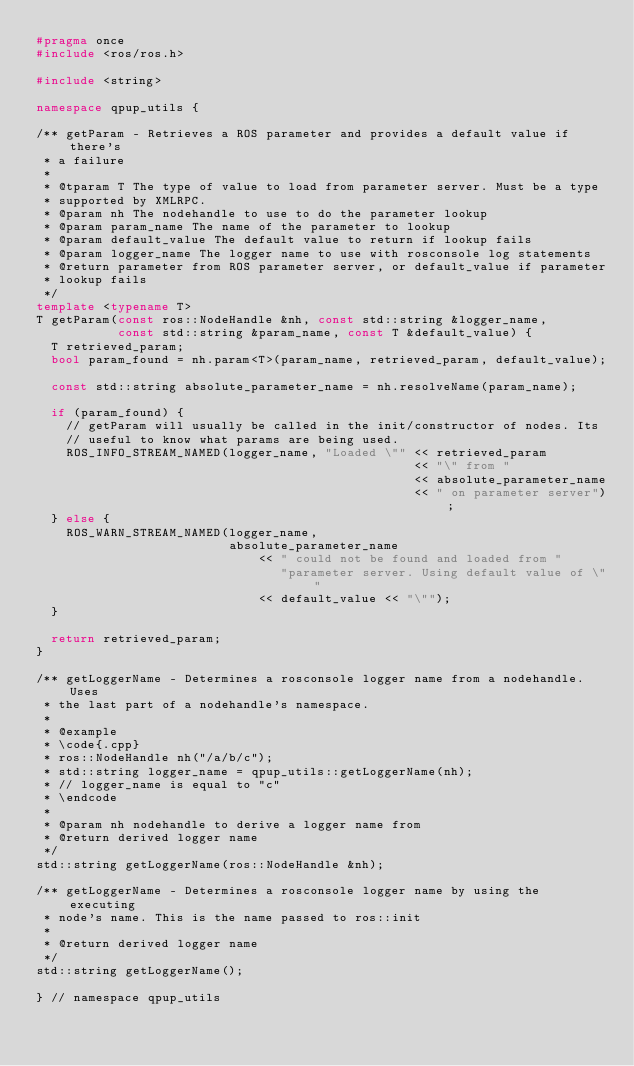<code> <loc_0><loc_0><loc_500><loc_500><_C++_>#pragma once
#include <ros/ros.h>

#include <string>

namespace qpup_utils {

/** getParam - Retrieves a ROS parameter and provides a default value if there's
 * a failure
 *
 * @tparam T The type of value to load from parameter server. Must be a type
 * supported by XMLRPC.
 * @param nh The nodehandle to use to do the parameter lookup
 * @param param_name The name of the parameter to lookup
 * @param default_value The default value to return if lookup fails
 * @param logger_name The logger name to use with rosconsole log statements
 * @return parameter from ROS parameter server, or default_value if parameter
 * lookup fails
 */
template <typename T>
T getParam(const ros::NodeHandle &nh, const std::string &logger_name,
           const std::string &param_name, const T &default_value) {
  T retrieved_param;
  bool param_found = nh.param<T>(param_name, retrieved_param, default_value);

  const std::string absolute_parameter_name = nh.resolveName(param_name);

  if (param_found) {
    // getParam will usually be called in the init/constructor of nodes. Its
    // useful to know what params are being used.
    ROS_INFO_STREAM_NAMED(logger_name, "Loaded \"" << retrieved_param
                                                   << "\" from "
                                                   << absolute_parameter_name
                                                   << " on parameter server");
  } else {
    ROS_WARN_STREAM_NAMED(logger_name,
                          absolute_parameter_name
                              << " could not be found and loaded from "
                                 "parameter server. Using default value of \""
                              << default_value << "\"");
  }

  return retrieved_param;
}

/** getLoggerName - Determines a rosconsole logger name from a nodehandle. Uses
 * the last part of a nodehandle's namespace.
 *
 * @example
 * \code{.cpp}
 * ros::NodeHandle nh("/a/b/c");
 * std::string logger_name = qpup_utils::getLoggerName(nh);
 * // logger_name is equal to "c"
 * \endcode
 *
 * @param nh nodehandle to derive a logger name from
 * @return derived logger name
 */
std::string getLoggerName(ros::NodeHandle &nh);

/** getLoggerName - Determines a rosconsole logger name by using the executing
 * node's name. This is the name passed to ros::init
 *
 * @return derived logger name
 */
std::string getLoggerName();

} // namespace qpup_utils
</code> 